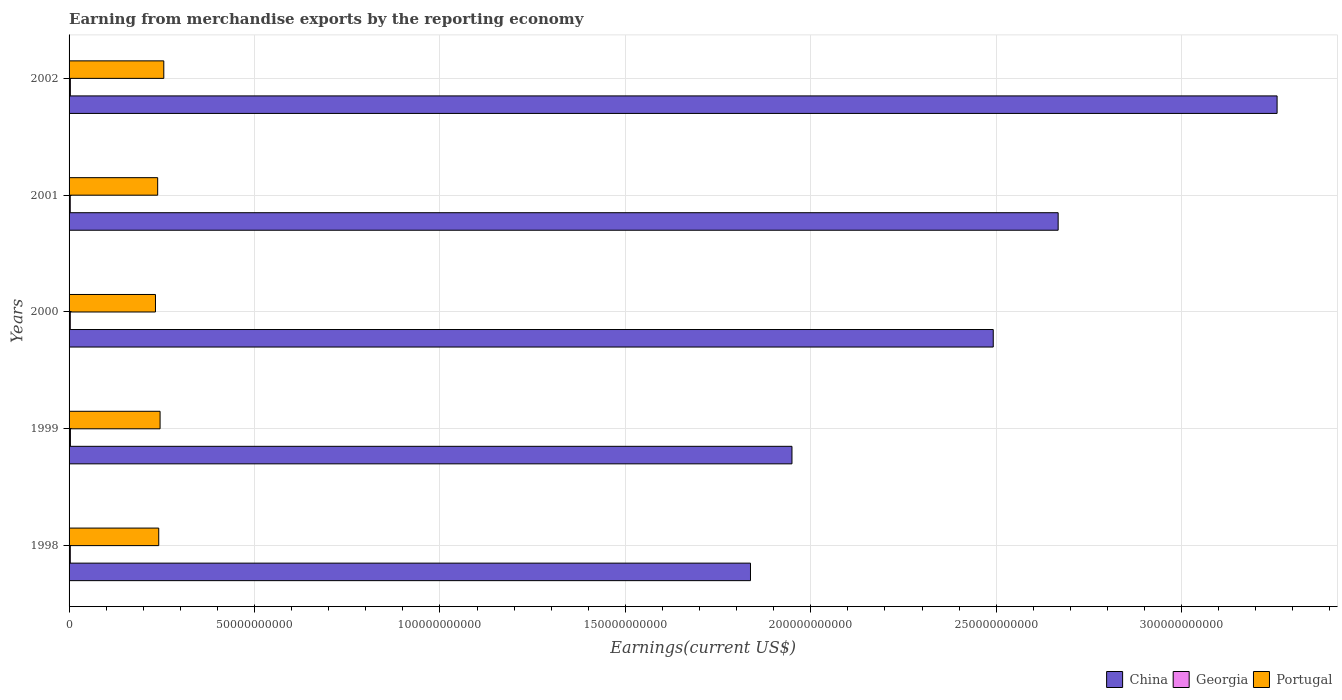How many groups of bars are there?
Offer a terse response. 5. Are the number of bars per tick equal to the number of legend labels?
Your response must be concise. Yes. Are the number of bars on each tick of the Y-axis equal?
Ensure brevity in your answer.  Yes. In how many cases, is the number of bars for a given year not equal to the number of legend labels?
Your answer should be compact. 0. What is the amount earned from merchandise exports in Georgia in 1999?
Your answer should be very brief. 3.61e+08. Across all years, what is the maximum amount earned from merchandise exports in Georgia?
Your answer should be compact. 3.61e+08. Across all years, what is the minimum amount earned from merchandise exports in Georgia?
Provide a succinct answer. 3.17e+08. In which year was the amount earned from merchandise exports in Georgia minimum?
Keep it short and to the point. 2001. What is the total amount earned from merchandise exports in China in the graph?
Your answer should be compact. 1.22e+12. What is the difference between the amount earned from merchandise exports in China in 2000 and that in 2002?
Provide a succinct answer. -7.65e+1. What is the difference between the amount earned from merchandise exports in China in 1999 and the amount earned from merchandise exports in Georgia in 2002?
Your response must be concise. 1.95e+11. What is the average amount earned from merchandise exports in China per year?
Offer a very short reply. 2.44e+11. In the year 2000, what is the difference between the amount earned from merchandise exports in China and amount earned from merchandise exports in Georgia?
Provide a succinct answer. 2.49e+11. In how many years, is the amount earned from merchandise exports in China greater than 190000000000 US$?
Offer a terse response. 4. What is the ratio of the amount earned from merchandise exports in China in 1999 to that in 2002?
Keep it short and to the point. 0.6. Is the amount earned from merchandise exports in Georgia in 2000 less than that in 2002?
Make the answer very short. Yes. What is the difference between the highest and the second highest amount earned from merchandise exports in Georgia?
Make the answer very short. 1.16e+07. What is the difference between the highest and the lowest amount earned from merchandise exports in China?
Make the answer very short. 1.42e+11. Is the sum of the amount earned from merchandise exports in Portugal in 1999 and 2000 greater than the maximum amount earned from merchandise exports in China across all years?
Keep it short and to the point. No. What does the 1st bar from the top in 2000 represents?
Provide a succinct answer. Portugal. What does the 3rd bar from the bottom in 1999 represents?
Your answer should be very brief. Portugal. How many bars are there?
Ensure brevity in your answer.  15. Are all the bars in the graph horizontal?
Your response must be concise. Yes. How many years are there in the graph?
Keep it short and to the point. 5. Are the values on the major ticks of X-axis written in scientific E-notation?
Provide a succinct answer. No. Does the graph contain any zero values?
Make the answer very short. No. Does the graph contain grids?
Offer a terse response. Yes. How many legend labels are there?
Your answer should be compact. 3. What is the title of the graph?
Offer a terse response. Earning from merchandise exports by the reporting economy. Does "Colombia" appear as one of the legend labels in the graph?
Give a very brief answer. No. What is the label or title of the X-axis?
Give a very brief answer. Earnings(current US$). What is the label or title of the Y-axis?
Make the answer very short. Years. What is the Earnings(current US$) of China in 1998?
Keep it short and to the point. 1.84e+11. What is the Earnings(current US$) of Georgia in 1998?
Provide a short and direct response. 3.31e+08. What is the Earnings(current US$) in Portugal in 1998?
Offer a terse response. 2.42e+1. What is the Earnings(current US$) in China in 1999?
Give a very brief answer. 1.95e+11. What is the Earnings(current US$) in Georgia in 1999?
Keep it short and to the point. 3.61e+08. What is the Earnings(current US$) in Portugal in 1999?
Keep it short and to the point. 2.45e+1. What is the Earnings(current US$) of China in 2000?
Provide a succinct answer. 2.49e+11. What is the Earnings(current US$) of Georgia in 2000?
Your answer should be compact. 3.26e+08. What is the Earnings(current US$) of Portugal in 2000?
Your response must be concise. 2.33e+1. What is the Earnings(current US$) of China in 2001?
Keep it short and to the point. 2.67e+11. What is the Earnings(current US$) of Georgia in 2001?
Offer a very short reply. 3.17e+08. What is the Earnings(current US$) in Portugal in 2001?
Provide a short and direct response. 2.39e+1. What is the Earnings(current US$) of China in 2002?
Offer a very short reply. 3.26e+11. What is the Earnings(current US$) of Georgia in 2002?
Your answer should be compact. 3.49e+08. What is the Earnings(current US$) of Portugal in 2002?
Provide a succinct answer. 2.55e+1. Across all years, what is the maximum Earnings(current US$) of China?
Make the answer very short. 3.26e+11. Across all years, what is the maximum Earnings(current US$) in Georgia?
Your answer should be very brief. 3.61e+08. Across all years, what is the maximum Earnings(current US$) of Portugal?
Provide a short and direct response. 2.55e+1. Across all years, what is the minimum Earnings(current US$) in China?
Give a very brief answer. 1.84e+11. Across all years, what is the minimum Earnings(current US$) in Georgia?
Make the answer very short. 3.17e+08. Across all years, what is the minimum Earnings(current US$) of Portugal?
Give a very brief answer. 2.33e+1. What is the total Earnings(current US$) in China in the graph?
Your response must be concise. 1.22e+12. What is the total Earnings(current US$) in Georgia in the graph?
Your response must be concise. 1.68e+09. What is the total Earnings(current US$) of Portugal in the graph?
Provide a succinct answer. 1.21e+11. What is the difference between the Earnings(current US$) of China in 1998 and that in 1999?
Your answer should be very brief. -1.12e+1. What is the difference between the Earnings(current US$) in Georgia in 1998 and that in 1999?
Ensure brevity in your answer.  -3.02e+07. What is the difference between the Earnings(current US$) in Portugal in 1998 and that in 1999?
Offer a terse response. -3.62e+08. What is the difference between the Earnings(current US$) of China in 1998 and that in 2000?
Offer a terse response. -6.55e+1. What is the difference between the Earnings(current US$) in Georgia in 1998 and that in 2000?
Your answer should be very brief. 4.80e+06. What is the difference between the Earnings(current US$) of Portugal in 1998 and that in 2000?
Provide a succinct answer. 8.82e+08. What is the difference between the Earnings(current US$) of China in 1998 and that in 2001?
Make the answer very short. -8.30e+1. What is the difference between the Earnings(current US$) in Georgia in 1998 and that in 2001?
Your response must be concise. 1.35e+07. What is the difference between the Earnings(current US$) of Portugal in 1998 and that in 2001?
Ensure brevity in your answer.  2.88e+08. What is the difference between the Earnings(current US$) of China in 1998 and that in 2002?
Your answer should be compact. -1.42e+11. What is the difference between the Earnings(current US$) in Georgia in 1998 and that in 2002?
Offer a terse response. -1.86e+07. What is the difference between the Earnings(current US$) in Portugal in 1998 and that in 2002?
Your response must be concise. -1.36e+09. What is the difference between the Earnings(current US$) of China in 1999 and that in 2000?
Make the answer very short. -5.43e+1. What is the difference between the Earnings(current US$) of Georgia in 1999 and that in 2000?
Provide a succinct answer. 3.50e+07. What is the difference between the Earnings(current US$) of Portugal in 1999 and that in 2000?
Your answer should be compact. 1.24e+09. What is the difference between the Earnings(current US$) of China in 1999 and that in 2001?
Provide a succinct answer. -7.18e+1. What is the difference between the Earnings(current US$) in Georgia in 1999 and that in 2001?
Provide a succinct answer. 4.37e+07. What is the difference between the Earnings(current US$) of Portugal in 1999 and that in 2001?
Provide a succinct answer. 6.50e+08. What is the difference between the Earnings(current US$) in China in 1999 and that in 2002?
Your answer should be compact. -1.31e+11. What is the difference between the Earnings(current US$) in Georgia in 1999 and that in 2002?
Ensure brevity in your answer.  1.16e+07. What is the difference between the Earnings(current US$) in Portugal in 1999 and that in 2002?
Make the answer very short. -1.00e+09. What is the difference between the Earnings(current US$) in China in 2000 and that in 2001?
Your answer should be very brief. -1.75e+1. What is the difference between the Earnings(current US$) of Georgia in 2000 and that in 2001?
Your response must be concise. 8.65e+06. What is the difference between the Earnings(current US$) in Portugal in 2000 and that in 2001?
Provide a succinct answer. -5.95e+08. What is the difference between the Earnings(current US$) of China in 2000 and that in 2002?
Give a very brief answer. -7.65e+1. What is the difference between the Earnings(current US$) in Georgia in 2000 and that in 2002?
Your answer should be very brief. -2.34e+07. What is the difference between the Earnings(current US$) of Portugal in 2000 and that in 2002?
Give a very brief answer. -2.25e+09. What is the difference between the Earnings(current US$) in China in 2001 and that in 2002?
Your answer should be very brief. -5.90e+1. What is the difference between the Earnings(current US$) in Georgia in 2001 and that in 2002?
Keep it short and to the point. -3.21e+07. What is the difference between the Earnings(current US$) of Portugal in 2001 and that in 2002?
Provide a succinct answer. -1.65e+09. What is the difference between the Earnings(current US$) in China in 1998 and the Earnings(current US$) in Georgia in 1999?
Keep it short and to the point. 1.83e+11. What is the difference between the Earnings(current US$) of China in 1998 and the Earnings(current US$) of Portugal in 1999?
Offer a very short reply. 1.59e+11. What is the difference between the Earnings(current US$) in Georgia in 1998 and the Earnings(current US$) in Portugal in 1999?
Make the answer very short. -2.42e+1. What is the difference between the Earnings(current US$) in China in 1998 and the Earnings(current US$) in Georgia in 2000?
Offer a terse response. 1.83e+11. What is the difference between the Earnings(current US$) in China in 1998 and the Earnings(current US$) in Portugal in 2000?
Keep it short and to the point. 1.60e+11. What is the difference between the Earnings(current US$) in Georgia in 1998 and the Earnings(current US$) in Portugal in 2000?
Keep it short and to the point. -2.30e+1. What is the difference between the Earnings(current US$) in China in 1998 and the Earnings(current US$) in Georgia in 2001?
Offer a very short reply. 1.83e+11. What is the difference between the Earnings(current US$) of China in 1998 and the Earnings(current US$) of Portugal in 2001?
Your answer should be compact. 1.60e+11. What is the difference between the Earnings(current US$) of Georgia in 1998 and the Earnings(current US$) of Portugal in 2001?
Your answer should be very brief. -2.36e+1. What is the difference between the Earnings(current US$) in China in 1998 and the Earnings(current US$) in Georgia in 2002?
Offer a terse response. 1.83e+11. What is the difference between the Earnings(current US$) of China in 1998 and the Earnings(current US$) of Portugal in 2002?
Your answer should be compact. 1.58e+11. What is the difference between the Earnings(current US$) of Georgia in 1998 and the Earnings(current US$) of Portugal in 2002?
Provide a succinct answer. -2.52e+1. What is the difference between the Earnings(current US$) in China in 1999 and the Earnings(current US$) in Georgia in 2000?
Offer a terse response. 1.95e+11. What is the difference between the Earnings(current US$) of China in 1999 and the Earnings(current US$) of Portugal in 2000?
Your answer should be very brief. 1.72e+11. What is the difference between the Earnings(current US$) of Georgia in 1999 and the Earnings(current US$) of Portugal in 2000?
Provide a succinct answer. -2.29e+1. What is the difference between the Earnings(current US$) of China in 1999 and the Earnings(current US$) of Georgia in 2001?
Provide a succinct answer. 1.95e+11. What is the difference between the Earnings(current US$) in China in 1999 and the Earnings(current US$) in Portugal in 2001?
Your answer should be compact. 1.71e+11. What is the difference between the Earnings(current US$) in Georgia in 1999 and the Earnings(current US$) in Portugal in 2001?
Provide a succinct answer. -2.35e+1. What is the difference between the Earnings(current US$) in China in 1999 and the Earnings(current US$) in Georgia in 2002?
Your answer should be very brief. 1.95e+11. What is the difference between the Earnings(current US$) of China in 1999 and the Earnings(current US$) of Portugal in 2002?
Offer a terse response. 1.69e+11. What is the difference between the Earnings(current US$) in Georgia in 1999 and the Earnings(current US$) in Portugal in 2002?
Provide a succinct answer. -2.52e+1. What is the difference between the Earnings(current US$) in China in 2000 and the Earnings(current US$) in Georgia in 2001?
Give a very brief answer. 2.49e+11. What is the difference between the Earnings(current US$) in China in 2000 and the Earnings(current US$) in Portugal in 2001?
Make the answer very short. 2.25e+11. What is the difference between the Earnings(current US$) in Georgia in 2000 and the Earnings(current US$) in Portugal in 2001?
Your response must be concise. -2.36e+1. What is the difference between the Earnings(current US$) in China in 2000 and the Earnings(current US$) in Georgia in 2002?
Your response must be concise. 2.49e+11. What is the difference between the Earnings(current US$) of China in 2000 and the Earnings(current US$) of Portugal in 2002?
Offer a terse response. 2.24e+11. What is the difference between the Earnings(current US$) of Georgia in 2000 and the Earnings(current US$) of Portugal in 2002?
Your answer should be very brief. -2.52e+1. What is the difference between the Earnings(current US$) in China in 2001 and the Earnings(current US$) in Georgia in 2002?
Keep it short and to the point. 2.66e+11. What is the difference between the Earnings(current US$) in China in 2001 and the Earnings(current US$) in Portugal in 2002?
Keep it short and to the point. 2.41e+11. What is the difference between the Earnings(current US$) of Georgia in 2001 and the Earnings(current US$) of Portugal in 2002?
Offer a terse response. -2.52e+1. What is the average Earnings(current US$) in China per year?
Offer a terse response. 2.44e+11. What is the average Earnings(current US$) of Georgia per year?
Keep it short and to the point. 3.37e+08. What is the average Earnings(current US$) of Portugal per year?
Provide a short and direct response. 2.43e+1. In the year 1998, what is the difference between the Earnings(current US$) in China and Earnings(current US$) in Georgia?
Offer a terse response. 1.83e+11. In the year 1998, what is the difference between the Earnings(current US$) in China and Earnings(current US$) in Portugal?
Ensure brevity in your answer.  1.60e+11. In the year 1998, what is the difference between the Earnings(current US$) in Georgia and Earnings(current US$) in Portugal?
Provide a short and direct response. -2.38e+1. In the year 1999, what is the difference between the Earnings(current US$) in China and Earnings(current US$) in Georgia?
Give a very brief answer. 1.95e+11. In the year 1999, what is the difference between the Earnings(current US$) in China and Earnings(current US$) in Portugal?
Provide a short and direct response. 1.70e+11. In the year 1999, what is the difference between the Earnings(current US$) of Georgia and Earnings(current US$) of Portugal?
Offer a very short reply. -2.42e+1. In the year 2000, what is the difference between the Earnings(current US$) in China and Earnings(current US$) in Georgia?
Ensure brevity in your answer.  2.49e+11. In the year 2000, what is the difference between the Earnings(current US$) of China and Earnings(current US$) of Portugal?
Ensure brevity in your answer.  2.26e+11. In the year 2000, what is the difference between the Earnings(current US$) in Georgia and Earnings(current US$) in Portugal?
Your answer should be very brief. -2.30e+1. In the year 2001, what is the difference between the Earnings(current US$) of China and Earnings(current US$) of Georgia?
Your answer should be very brief. 2.66e+11. In the year 2001, what is the difference between the Earnings(current US$) of China and Earnings(current US$) of Portugal?
Keep it short and to the point. 2.43e+11. In the year 2001, what is the difference between the Earnings(current US$) in Georgia and Earnings(current US$) in Portugal?
Give a very brief answer. -2.36e+1. In the year 2002, what is the difference between the Earnings(current US$) of China and Earnings(current US$) of Georgia?
Provide a short and direct response. 3.25e+11. In the year 2002, what is the difference between the Earnings(current US$) in China and Earnings(current US$) in Portugal?
Offer a very short reply. 3.00e+11. In the year 2002, what is the difference between the Earnings(current US$) in Georgia and Earnings(current US$) in Portugal?
Offer a very short reply. -2.52e+1. What is the ratio of the Earnings(current US$) in China in 1998 to that in 1999?
Your answer should be very brief. 0.94. What is the ratio of the Earnings(current US$) in Georgia in 1998 to that in 1999?
Provide a short and direct response. 0.92. What is the ratio of the Earnings(current US$) of Portugal in 1998 to that in 1999?
Your answer should be very brief. 0.99. What is the ratio of the Earnings(current US$) of China in 1998 to that in 2000?
Your response must be concise. 0.74. What is the ratio of the Earnings(current US$) in Georgia in 1998 to that in 2000?
Make the answer very short. 1.01. What is the ratio of the Earnings(current US$) of Portugal in 1998 to that in 2000?
Provide a short and direct response. 1.04. What is the ratio of the Earnings(current US$) in China in 1998 to that in 2001?
Keep it short and to the point. 0.69. What is the ratio of the Earnings(current US$) of Georgia in 1998 to that in 2001?
Your answer should be very brief. 1.04. What is the ratio of the Earnings(current US$) in China in 1998 to that in 2002?
Offer a terse response. 0.56. What is the ratio of the Earnings(current US$) in Georgia in 1998 to that in 2002?
Your response must be concise. 0.95. What is the ratio of the Earnings(current US$) of Portugal in 1998 to that in 2002?
Ensure brevity in your answer.  0.95. What is the ratio of the Earnings(current US$) of China in 1999 to that in 2000?
Your response must be concise. 0.78. What is the ratio of the Earnings(current US$) of Georgia in 1999 to that in 2000?
Make the answer very short. 1.11. What is the ratio of the Earnings(current US$) in Portugal in 1999 to that in 2000?
Offer a terse response. 1.05. What is the ratio of the Earnings(current US$) of China in 1999 to that in 2001?
Your answer should be compact. 0.73. What is the ratio of the Earnings(current US$) in Georgia in 1999 to that in 2001?
Provide a succinct answer. 1.14. What is the ratio of the Earnings(current US$) in Portugal in 1999 to that in 2001?
Your answer should be very brief. 1.03. What is the ratio of the Earnings(current US$) of China in 1999 to that in 2002?
Your answer should be very brief. 0.6. What is the ratio of the Earnings(current US$) in Portugal in 1999 to that in 2002?
Give a very brief answer. 0.96. What is the ratio of the Earnings(current US$) of China in 2000 to that in 2001?
Offer a terse response. 0.93. What is the ratio of the Earnings(current US$) of Georgia in 2000 to that in 2001?
Ensure brevity in your answer.  1.03. What is the ratio of the Earnings(current US$) in Portugal in 2000 to that in 2001?
Your answer should be compact. 0.98. What is the ratio of the Earnings(current US$) of China in 2000 to that in 2002?
Offer a very short reply. 0.77. What is the ratio of the Earnings(current US$) in Georgia in 2000 to that in 2002?
Your response must be concise. 0.93. What is the ratio of the Earnings(current US$) of Portugal in 2000 to that in 2002?
Give a very brief answer. 0.91. What is the ratio of the Earnings(current US$) in China in 2001 to that in 2002?
Provide a succinct answer. 0.82. What is the ratio of the Earnings(current US$) in Georgia in 2001 to that in 2002?
Keep it short and to the point. 0.91. What is the ratio of the Earnings(current US$) of Portugal in 2001 to that in 2002?
Offer a terse response. 0.94. What is the difference between the highest and the second highest Earnings(current US$) of China?
Provide a short and direct response. 5.90e+1. What is the difference between the highest and the second highest Earnings(current US$) in Georgia?
Offer a terse response. 1.16e+07. What is the difference between the highest and the second highest Earnings(current US$) in Portugal?
Make the answer very short. 1.00e+09. What is the difference between the highest and the lowest Earnings(current US$) in China?
Provide a short and direct response. 1.42e+11. What is the difference between the highest and the lowest Earnings(current US$) in Georgia?
Give a very brief answer. 4.37e+07. What is the difference between the highest and the lowest Earnings(current US$) of Portugal?
Make the answer very short. 2.25e+09. 